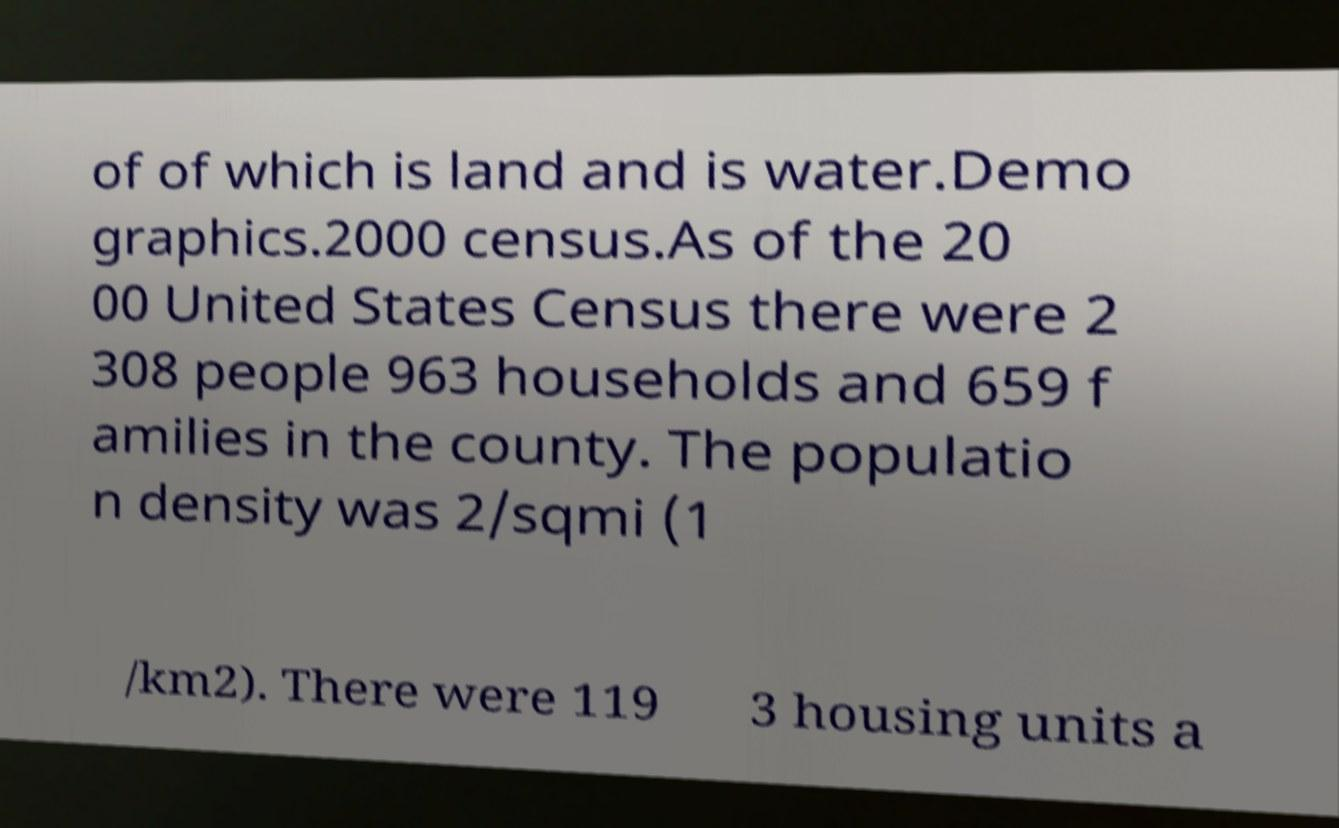What messages or text are displayed in this image? I need them in a readable, typed format. of of which is land and is water.Demo graphics.2000 census.As of the 20 00 United States Census there were 2 308 people 963 households and 659 f amilies in the county. The populatio n density was 2/sqmi (1 /km2). There were 119 3 housing units a 